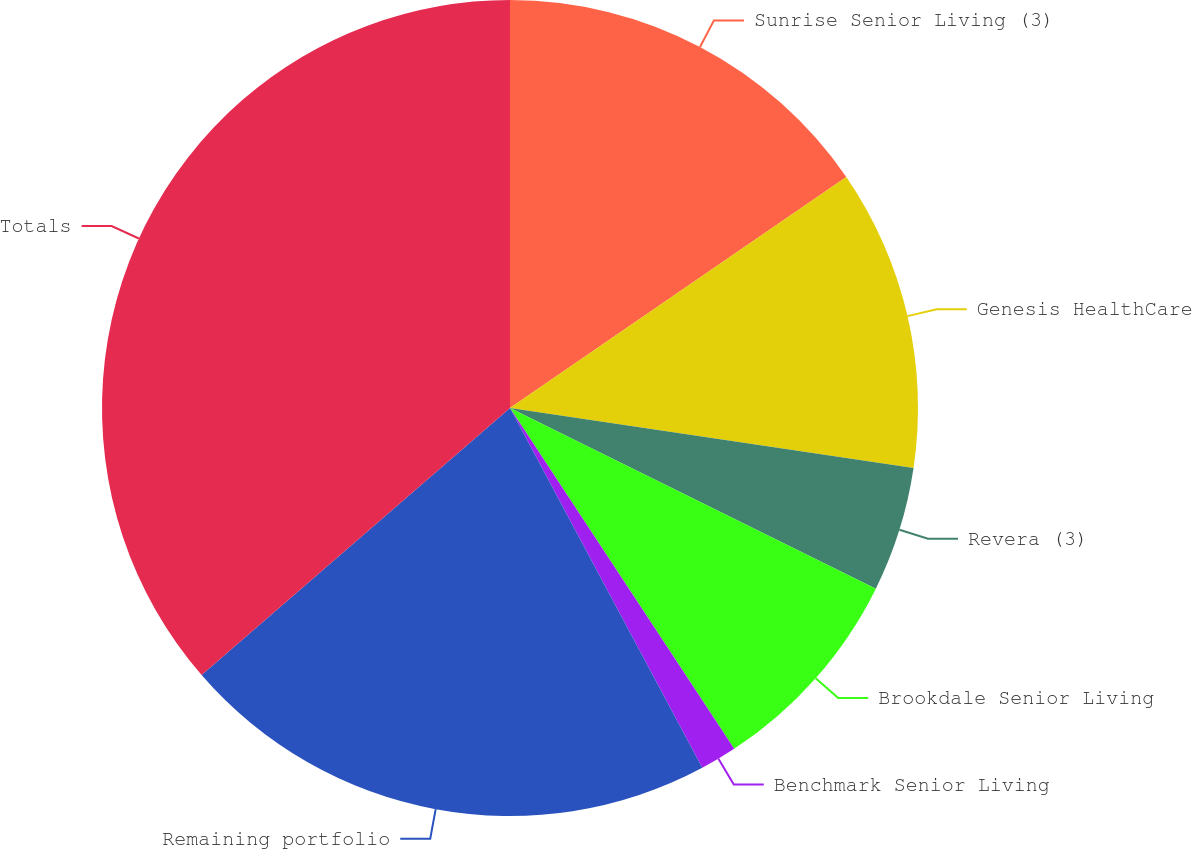Convert chart. <chart><loc_0><loc_0><loc_500><loc_500><pie_chart><fcel>Sunrise Senior Living (3)<fcel>Genesis HealthCare<fcel>Revera (3)<fcel>Brookdale Senior Living<fcel>Benchmark Senior Living<fcel>Remaining portfolio<fcel>Totals<nl><fcel>15.42%<fcel>11.93%<fcel>4.95%<fcel>8.44%<fcel>1.45%<fcel>21.45%<fcel>36.36%<nl></chart> 